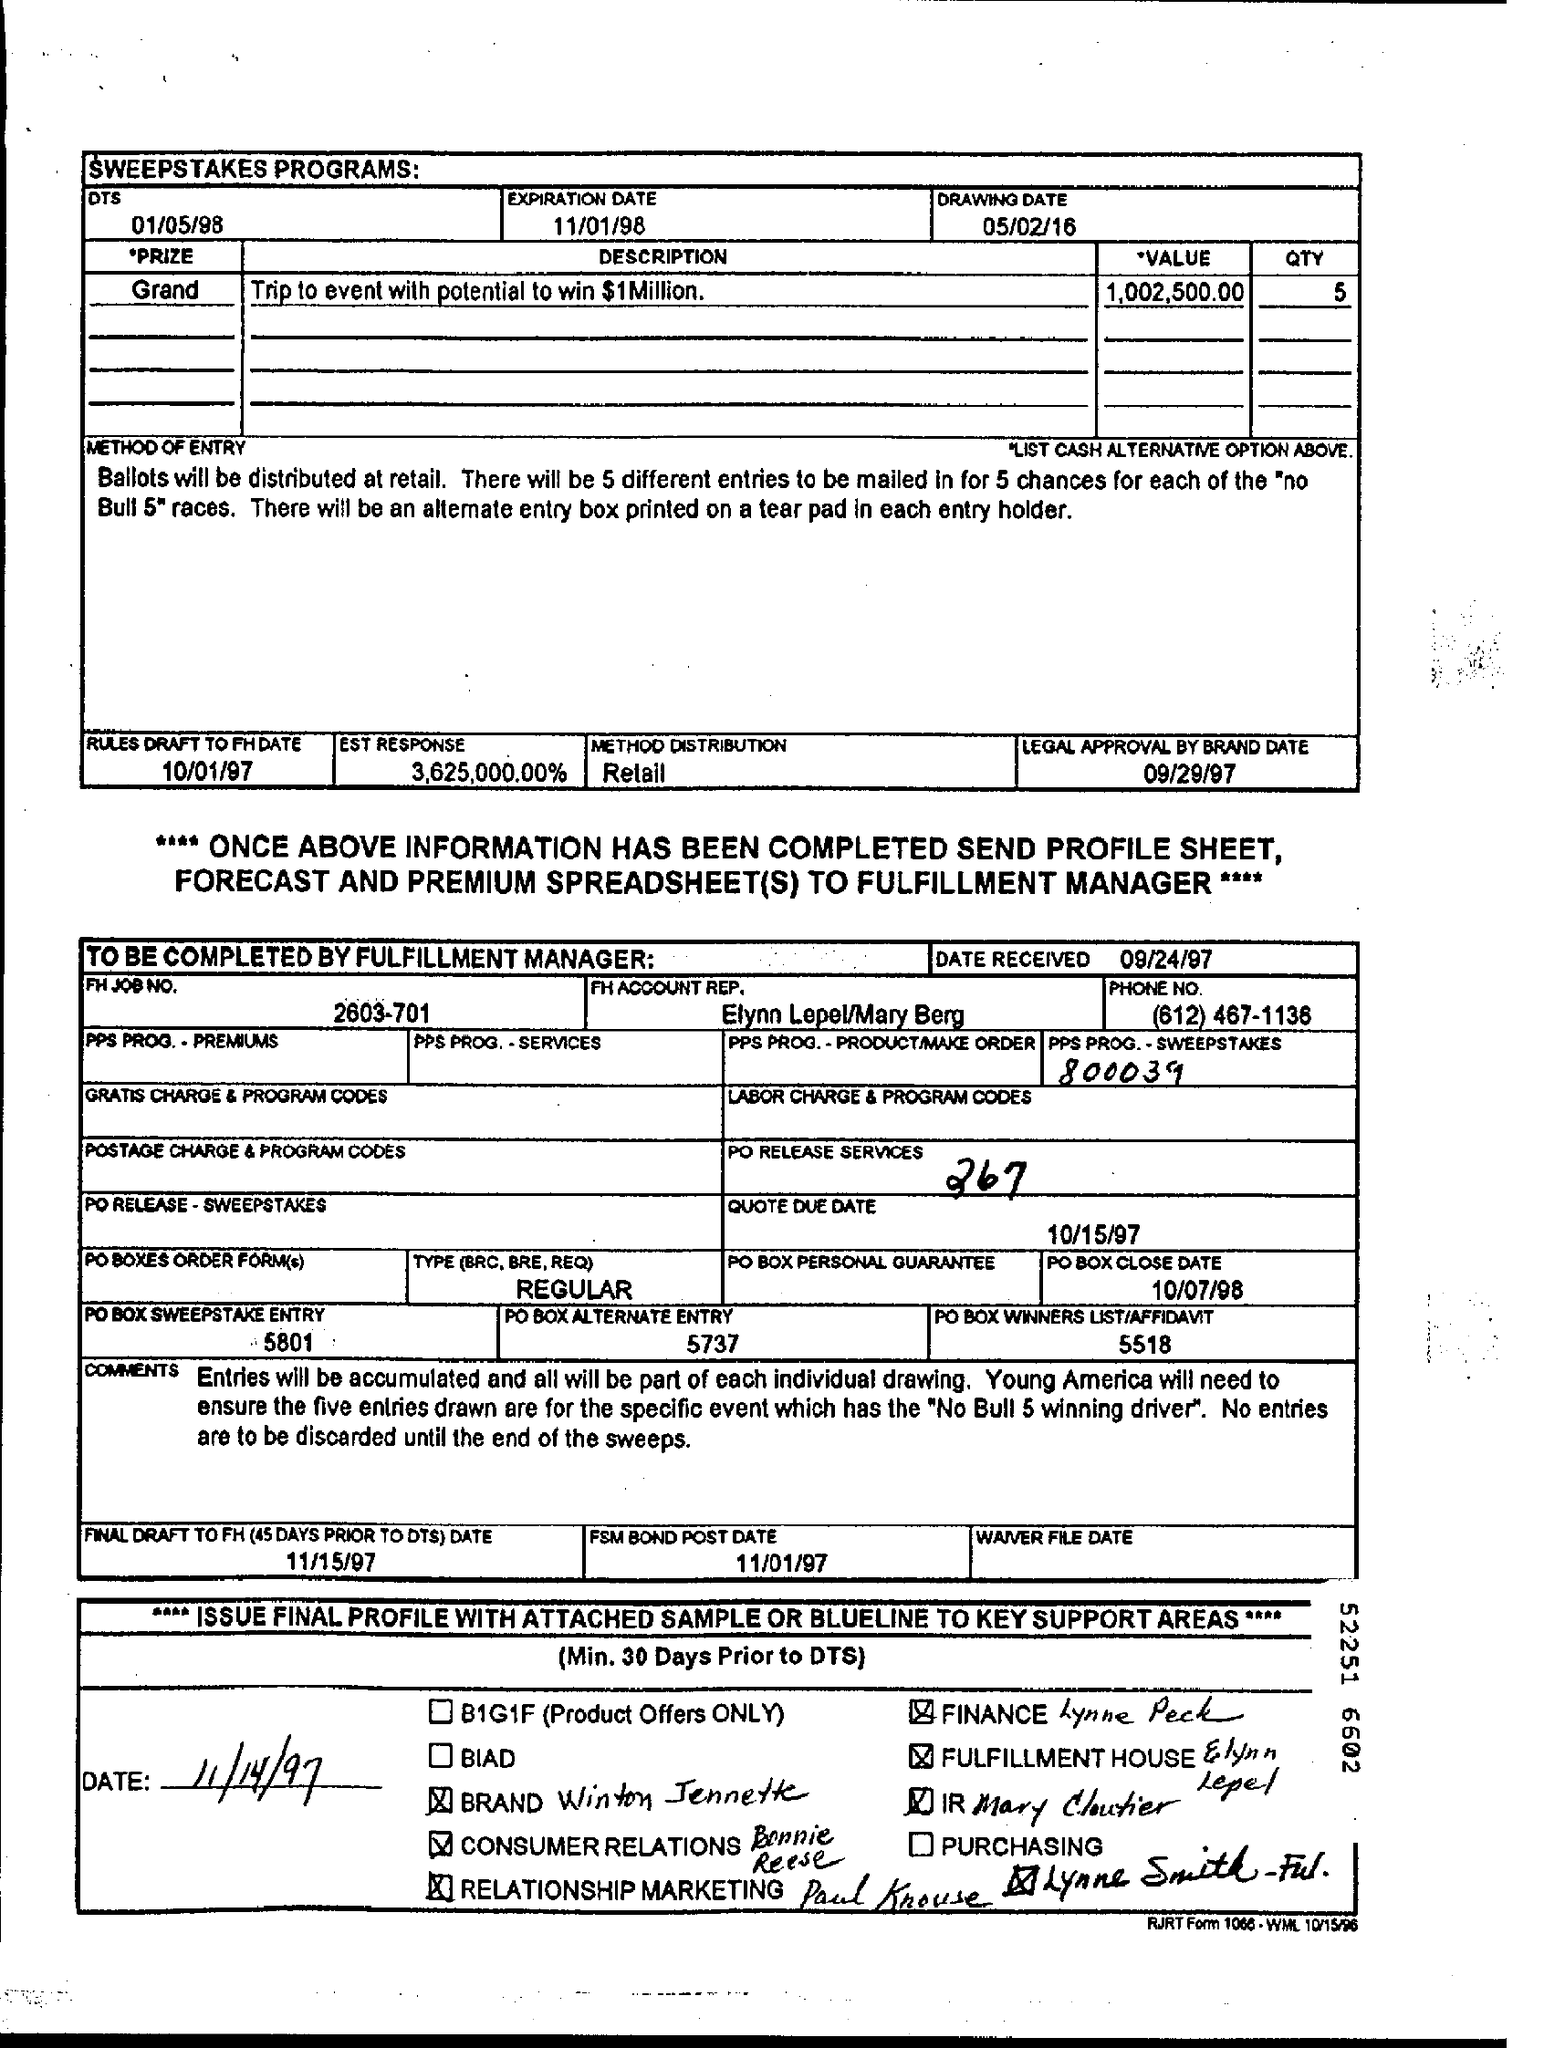When is the expiration date?
Give a very brief answer. 11/01/98. When is the drawing date of the sweepstakes programs?
Offer a very short reply. 05/02/16. What is the prize description?
Offer a terse response. Trip to event with potential to win $1 Million. What is the value of the prize?
Give a very brief answer. 1,002,500.00. What is the method distribution?
Keep it short and to the point. Retail. 